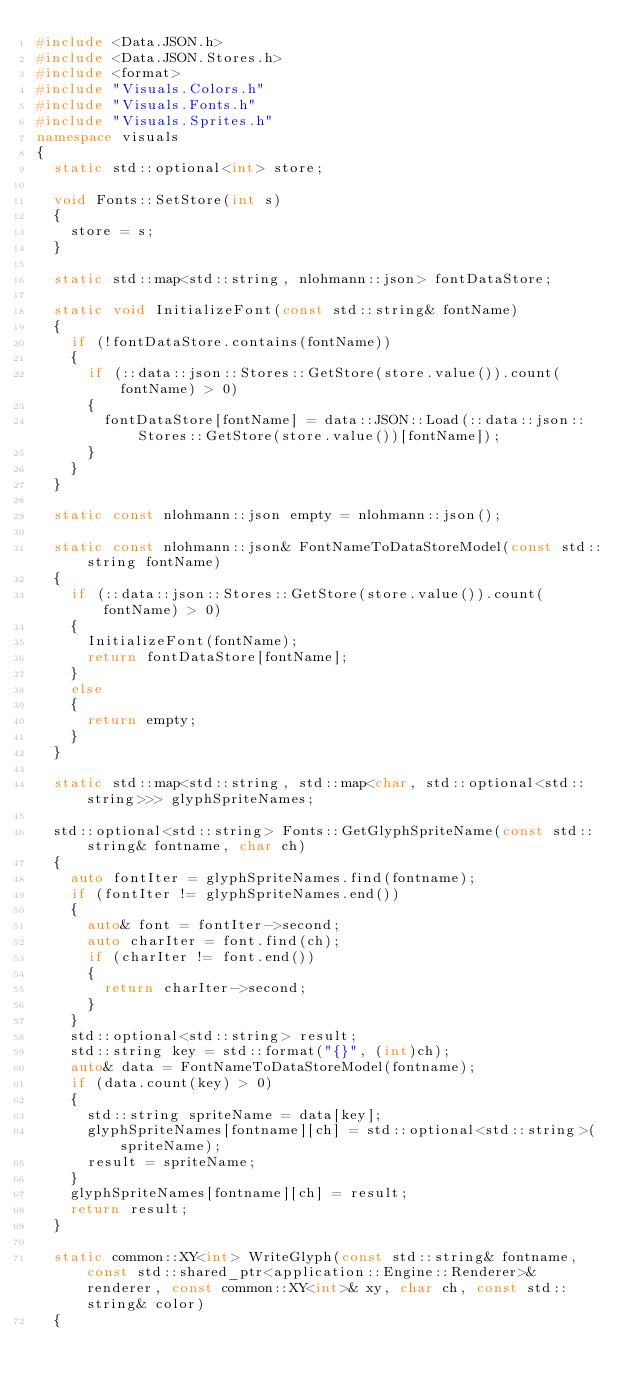<code> <loc_0><loc_0><loc_500><loc_500><_C++_>#include <Data.JSON.h>
#include <Data.JSON.Stores.h>
#include <format>
#include "Visuals.Colors.h"
#include "Visuals.Fonts.h"
#include "Visuals.Sprites.h"
namespace visuals
{
	static std::optional<int> store;

	void Fonts::SetStore(int s)
	{
		store = s;
	}

	static std::map<std::string, nlohmann::json> fontDataStore;

	static void InitializeFont(const std::string& fontName)
	{
		if (!fontDataStore.contains(fontName))
		{
			if (::data::json::Stores::GetStore(store.value()).count(fontName) > 0)
			{
				fontDataStore[fontName] = data::JSON::Load(::data::json::Stores::GetStore(store.value())[fontName]);
			}
		}
	}

	static const nlohmann::json empty = nlohmann::json();

	static const nlohmann::json& FontNameToDataStoreModel(const std::string fontName)
	{
		if (::data::json::Stores::GetStore(store.value()).count(fontName) > 0)
		{
			InitializeFont(fontName);
			return fontDataStore[fontName];
		}
		else
		{
			return empty;
		}
	}

	static std::map<std::string, std::map<char, std::optional<std::string>>> glyphSpriteNames;

	std::optional<std::string> Fonts::GetGlyphSpriteName(const std::string& fontname, char ch)
	{
		auto fontIter = glyphSpriteNames.find(fontname);
		if (fontIter != glyphSpriteNames.end())
		{
			auto& font = fontIter->second;
			auto charIter = font.find(ch);
			if (charIter != font.end())
			{
				return charIter->second;
			}
		}
		std::optional<std::string> result;
		std::string key = std::format("{}", (int)ch);
		auto& data = FontNameToDataStoreModel(fontname);
		if (data.count(key) > 0)
		{
			std::string spriteName = data[key];
			glyphSpriteNames[fontname][ch] = std::optional<std::string>(spriteName);
			result = spriteName;
		}
		glyphSpriteNames[fontname][ch] = result;
		return result;
	}

	static common::XY<int> WriteGlyph(const std::string& fontname, const std::shared_ptr<application::Engine::Renderer>& renderer, const common::XY<int>& xy, char ch, const std::string& color)
	{</code> 